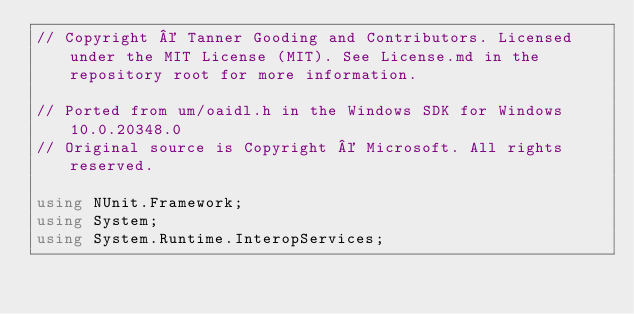Convert code to text. <code><loc_0><loc_0><loc_500><loc_500><_C#_>// Copyright © Tanner Gooding and Contributors. Licensed under the MIT License (MIT). See License.md in the repository root for more information.

// Ported from um/oaidl.h in the Windows SDK for Windows 10.0.20348.0
// Original source is Copyright © Microsoft. All rights reserved.

using NUnit.Framework;
using System;
using System.Runtime.InteropServices;</code> 